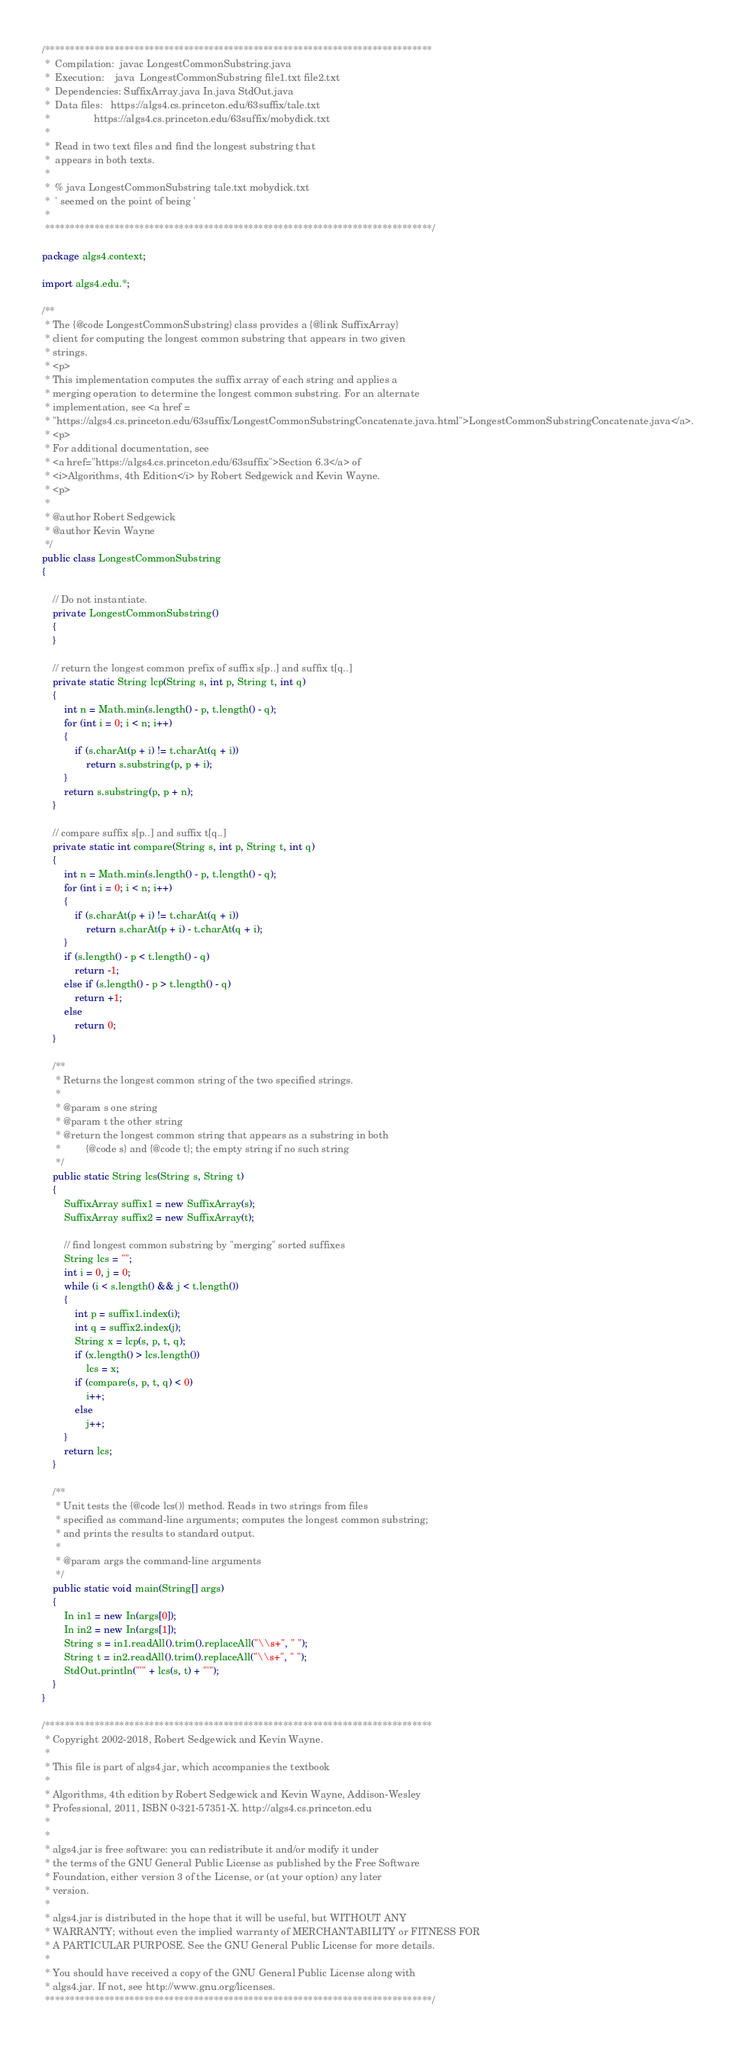Convert code to text. <code><loc_0><loc_0><loc_500><loc_500><_Java_>/******************************************************************************
 *  Compilation:  javac LongestCommonSubstring.java
 *  Execution:    java  LongestCommonSubstring file1.txt file2.txt
 *  Dependencies: SuffixArray.java In.java StdOut.java
 *  Data files:   https://algs4.cs.princeton.edu/63suffix/tale.txt
 *                https://algs4.cs.princeton.edu/63suffix/mobydick.txt
 *
 *  Read in two text files and find the longest substring that
 *  appears in both texts.
 *
 *  % java LongestCommonSubstring tale.txt mobydick.txt
 *  ' seemed on the point of being '
 *
 ******************************************************************************/

package algs4.context;

import algs4.edu.*;

/**
 * The {@code LongestCommonSubstring} class provides a {@link SuffixArray}
 * client for computing the longest common substring that appears in two given
 * strings.
 * <p>
 * This implementation computes the suffix array of each string and applies a
 * merging operation to determine the longest common substring. For an alternate
 * implementation, see <a href =
 * "https://algs4.cs.princeton.edu/63suffix/LongestCommonSubstringConcatenate.java.html">LongestCommonSubstringConcatenate.java</a>.
 * <p>
 * For additional documentation, see
 * <a href="https://algs4.cs.princeton.edu/63suffix">Section 6.3</a> of
 * <i>Algorithms, 4th Edition</i> by Robert Sedgewick and Kevin Wayne.
 * <p>
 *
 * @author Robert Sedgewick
 * @author Kevin Wayne
 */
public class LongestCommonSubstring
{

	// Do not instantiate.
	private LongestCommonSubstring()
	{
	}

	// return the longest common prefix of suffix s[p..] and suffix t[q..]
	private static String lcp(String s, int p, String t, int q)
	{
		int n = Math.min(s.length() - p, t.length() - q);
		for (int i = 0; i < n; i++)
		{
			if (s.charAt(p + i) != t.charAt(q + i))
				return s.substring(p, p + i);
		}
		return s.substring(p, p + n);
	}

	// compare suffix s[p..] and suffix t[q..]
	private static int compare(String s, int p, String t, int q)
	{
		int n = Math.min(s.length() - p, t.length() - q);
		for (int i = 0; i < n; i++)
		{
			if (s.charAt(p + i) != t.charAt(q + i))
				return s.charAt(p + i) - t.charAt(q + i);
		}
		if (s.length() - p < t.length() - q)
			return -1;
		else if (s.length() - p > t.length() - q)
			return +1;
		else
			return 0;
	}

	/**
	 * Returns the longest common string of the two specified strings.
	 *
	 * @param s one string
	 * @param t the other string
	 * @return the longest common string that appears as a substring in both
	 *         {@code s} and {@code t}; the empty string if no such string
	 */
	public static String lcs(String s, String t)
	{
		SuffixArray suffix1 = new SuffixArray(s);
		SuffixArray suffix2 = new SuffixArray(t);

		// find longest common substring by "merging" sorted suffixes
		String lcs = "";
		int i = 0, j = 0;
		while (i < s.length() && j < t.length())
		{
			int p = suffix1.index(i);
			int q = suffix2.index(j);
			String x = lcp(s, p, t, q);
			if (x.length() > lcs.length())
				lcs = x;
			if (compare(s, p, t, q) < 0)
				i++;
			else
				j++;
		}
		return lcs;
	}

	/**
	 * Unit tests the {@code lcs()} method. Reads in two strings from files
	 * specified as command-line arguments; computes the longest common substring;
	 * and prints the results to standard output.
	 *
	 * @param args the command-line arguments
	 */
	public static void main(String[] args)
	{
		In in1 = new In(args[0]);
		In in2 = new In(args[1]);
		String s = in1.readAll().trim().replaceAll("\\s+", " ");
		String t = in2.readAll().trim().replaceAll("\\s+", " ");
		StdOut.println("'" + lcs(s, t) + "'");
	}
}

/******************************************************************************
 * Copyright 2002-2018, Robert Sedgewick and Kevin Wayne.
 *
 * This file is part of algs4.jar, which accompanies the textbook
 *
 * Algorithms, 4th edition by Robert Sedgewick and Kevin Wayne, Addison-Wesley
 * Professional, 2011, ISBN 0-321-57351-X. http://algs4.cs.princeton.edu
 *
 *
 * algs4.jar is free software: you can redistribute it and/or modify it under
 * the terms of the GNU General Public License as published by the Free Software
 * Foundation, either version 3 of the License, or (at your option) any later
 * version.
 *
 * algs4.jar is distributed in the hope that it will be useful, but WITHOUT ANY
 * WARRANTY; without even the implied warranty of MERCHANTABILITY or FITNESS FOR
 * A PARTICULAR PURPOSE. See the GNU General Public License for more details.
 *
 * You should have received a copy of the GNU General Public License along with
 * algs4.jar. If not, see http://www.gnu.org/licenses.
 ******************************************************************************/
</code> 